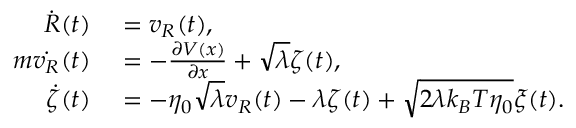Convert formula to latex. <formula><loc_0><loc_0><loc_500><loc_500>\begin{array} { r l } { \dot { R } ( t ) } & = v _ { R } ( t ) , } \\ { m \dot { v _ { R } } ( t ) } & = - \frac { \partial V ( x ) } { \partial x } + \sqrt { \lambda } \zeta ( t ) , } \\ { \dot { \zeta } ( t ) } & = - \eta _ { 0 } \sqrt { \lambda } v _ { R } ( t ) - \lambda \zeta ( t ) + \sqrt { 2 \lambda k _ { B } T \eta _ { 0 } } \xi ( t ) . } \end{array}</formula> 